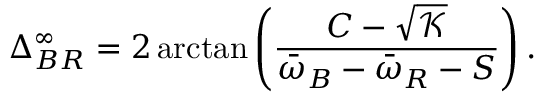Convert formula to latex. <formula><loc_0><loc_0><loc_500><loc_500>\Delta _ { B R } ^ { \infty } = 2 \arctan \left ( \frac { C - \sqrt { \mathcal { K } } } { \bar { \omega } _ { B } - \bar { \omega } _ { R } - S } \right ) .</formula> 